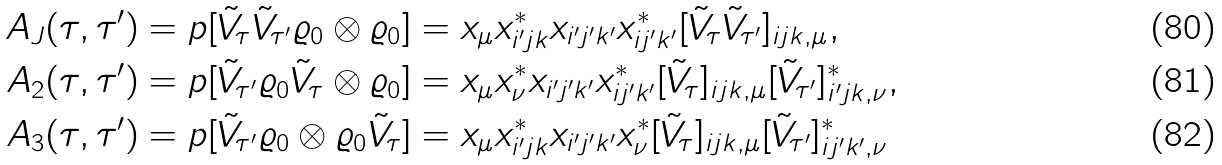Convert formula to latex. <formula><loc_0><loc_0><loc_500><loc_500>A _ { J } ( \tau , \tau ^ { \prime } ) & = p [ \tilde { V } _ { \tau } \tilde { V } _ { \tau ^ { \prime } } \varrho _ { 0 } \otimes \varrho _ { 0 } ] = x _ { \mu } x _ { i ^ { \prime } j k } ^ { * } x _ { i ^ { \prime } j ^ { \prime } k ^ { \prime } } x _ { i j ^ { \prime } k ^ { \prime } } ^ { * } [ \tilde { V } _ { \tau } \tilde { V } _ { \tau ^ { \prime } } ] _ { i j k , \mu } , \\ A _ { 2 } ( \tau , \tau ^ { \prime } ) & = p [ \tilde { V } _ { \tau ^ { \prime } } \varrho _ { 0 } \tilde { V } _ { \tau } \otimes \varrho _ { 0 } ] = x _ { \mu } x _ { \nu } ^ { * } x _ { i ^ { \prime } j ^ { \prime } k ^ { \prime } } x _ { i j ^ { \prime } k ^ { \prime } } ^ { * } [ \tilde { V } _ { \tau } ] _ { i j k , \mu } [ \tilde { V } _ { \tau ^ { \prime } } ] _ { i ^ { \prime } j k , \nu } ^ { * } , \\ A _ { 3 } ( \tau , \tau ^ { \prime } ) & = p [ \tilde { V } _ { \tau ^ { \prime } } \varrho _ { 0 } \otimes \varrho _ { 0 } \tilde { V } _ { \tau } ] = x _ { \mu } x _ { i ^ { \prime } j k } ^ { * } x _ { i ^ { \prime } j ^ { \prime } k ^ { \prime } } x _ { \nu } ^ { * } [ \tilde { V } _ { \tau } ] _ { i j k , \mu } [ \tilde { V } _ { \tau ^ { \prime } } ] _ { i j ^ { \prime } k ^ { \prime } , \nu } ^ { * }</formula> 